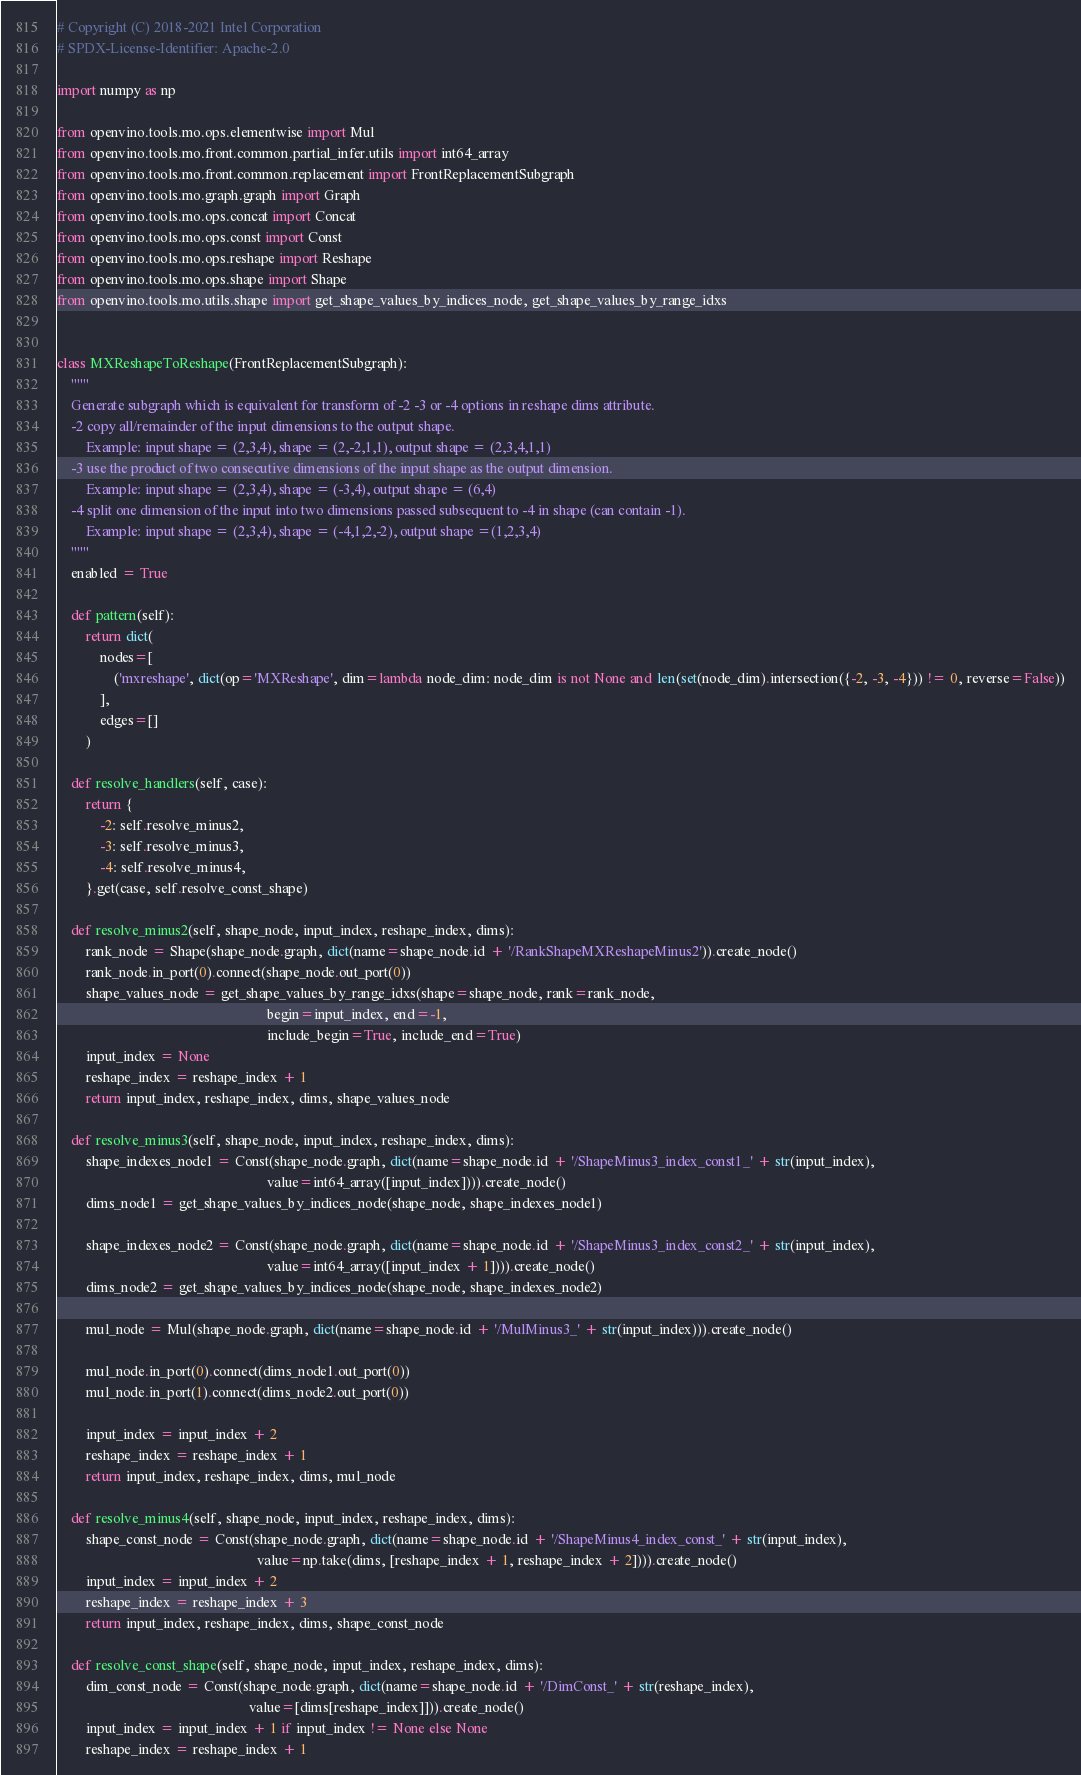Convert code to text. <code><loc_0><loc_0><loc_500><loc_500><_Python_># Copyright (C) 2018-2021 Intel Corporation
# SPDX-License-Identifier: Apache-2.0

import numpy as np

from openvino.tools.mo.ops.elementwise import Mul
from openvino.tools.mo.front.common.partial_infer.utils import int64_array
from openvino.tools.mo.front.common.replacement import FrontReplacementSubgraph
from openvino.tools.mo.graph.graph import Graph
from openvino.tools.mo.ops.concat import Concat
from openvino.tools.mo.ops.const import Const
from openvino.tools.mo.ops.reshape import Reshape
from openvino.tools.mo.ops.shape import Shape
from openvino.tools.mo.utils.shape import get_shape_values_by_indices_node, get_shape_values_by_range_idxs


class MXReshapeToReshape(FrontReplacementSubgraph):
    """
    Generate subgraph which is equivalent for transform of -2 -3 or -4 options in reshape dims attribute.
    -2 copy all/remainder of the input dimensions to the output shape.
        Example: input shape = (2,3,4), shape = (2,-2,1,1), output shape = (2,3,4,1,1)
    -3 use the product of two consecutive dimensions of the input shape as the output dimension.
        Example: input shape = (2,3,4), shape = (-3,4), output shape = (6,4)
    -4 split one dimension of the input into two dimensions passed subsequent to -4 in shape (can contain -1).
        Example: input shape = (2,3,4), shape = (-4,1,2,-2), output shape =(1,2,3,4)
    """
    enabled = True

    def pattern(self):
        return dict(
            nodes=[
                ('mxreshape', dict(op='MXReshape', dim=lambda node_dim: node_dim is not None and len(set(node_dim).intersection({-2, -3, -4})) != 0, reverse=False))
            ],
            edges=[]
        )

    def resolve_handlers(self, case):
        return {
            -2: self.resolve_minus2,
            -3: self.resolve_minus3,
            -4: self.resolve_minus4,
        }.get(case, self.resolve_const_shape)

    def resolve_minus2(self, shape_node, input_index, reshape_index, dims):
        rank_node = Shape(shape_node.graph, dict(name=shape_node.id + '/RankShapeMXReshapeMinus2')).create_node()
        rank_node.in_port(0).connect(shape_node.out_port(0))
        shape_values_node = get_shape_values_by_range_idxs(shape=shape_node, rank=rank_node,
                                                           begin=input_index, end=-1,
                                                           include_begin=True, include_end=True)
        input_index = None
        reshape_index = reshape_index + 1
        return input_index, reshape_index, dims, shape_values_node

    def resolve_minus3(self, shape_node, input_index, reshape_index, dims):
        shape_indexes_node1 = Const(shape_node.graph, dict(name=shape_node.id + '/ShapeMinus3_index_const1_' + str(input_index),
                                                           value=int64_array([input_index]))).create_node()
        dims_node1 = get_shape_values_by_indices_node(shape_node, shape_indexes_node1)

        shape_indexes_node2 = Const(shape_node.graph, dict(name=shape_node.id + '/ShapeMinus3_index_const2_' + str(input_index),
                                                           value=int64_array([input_index + 1]))).create_node()
        dims_node2 = get_shape_values_by_indices_node(shape_node, shape_indexes_node2)

        mul_node = Mul(shape_node.graph, dict(name=shape_node.id + '/MulMinus3_' + str(input_index))).create_node()

        mul_node.in_port(0).connect(dims_node1.out_port(0))
        mul_node.in_port(1).connect(dims_node2.out_port(0))

        input_index = input_index + 2
        reshape_index = reshape_index + 1
        return input_index, reshape_index, dims, mul_node

    def resolve_minus4(self, shape_node, input_index, reshape_index, dims):
        shape_const_node = Const(shape_node.graph, dict(name=shape_node.id + '/ShapeMinus4_index_const_' + str(input_index),
                                                        value=np.take(dims, [reshape_index + 1, reshape_index + 2]))).create_node()
        input_index = input_index + 2
        reshape_index = reshape_index + 3
        return input_index, reshape_index, dims, shape_const_node

    def resolve_const_shape(self, shape_node, input_index, reshape_index, dims):
        dim_const_node = Const(shape_node.graph, dict(name=shape_node.id + '/DimConst_' + str(reshape_index),
                                                      value=[dims[reshape_index]])).create_node()
        input_index = input_index + 1 if input_index != None else None
        reshape_index = reshape_index + 1</code> 